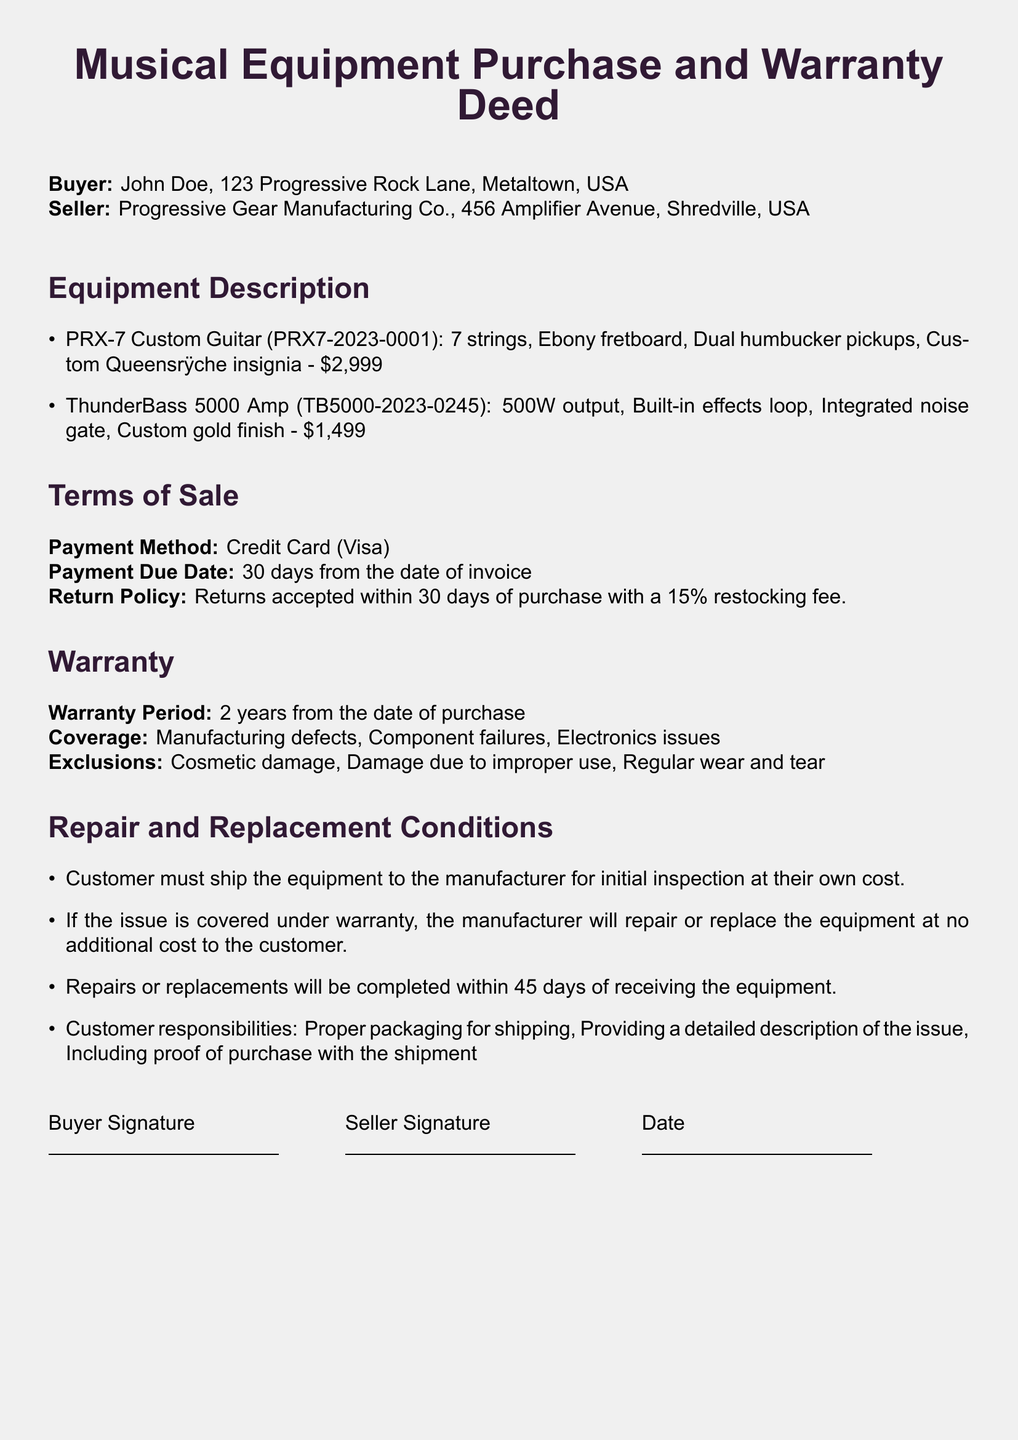What is the buyer's name? The buyer's name is clearly stated in the document as "John Doe."
Answer: John Doe What is the warranty period? The document specifies the warranty period as "2 years from the date of purchase."
Answer: 2 years What is the payment method used? The payment method is indicated in the terms of sale section as "Credit Card (Visa)."
Answer: Credit Card (Visa) What is the price of the PRX-7 Custom Guitar? The price for the PRX-7 Custom Guitar is listed explicitly as "$2,999."
Answer: $2,999 What must the customer include with the shipment for repairs? The document states that the customer must include "proof of purchase with the shipment."
Answer: proof of purchase What is the return policy within 30 days of purchase? The return policy mentions that "Returns accepted within 30 days of purchase with a 15% restocking fee."
Answer: Returns accepted within 30 days with a 15% restocking fee What is one exclusion from the warranty coverage? The document mentions "Cosmetic damage" as one of the exclusions under warranty coverage.
Answer: Cosmetic damage How long will repairs or replacements take? The document states that repairs or replacements will be completed "within 45 days of receiving the equipment."
Answer: 45 days What is the seller's address? The seller's address is outlined as "456 Amplifier Avenue, Shredville, USA."
Answer: 456 Amplifier Avenue, Shredville, USA 